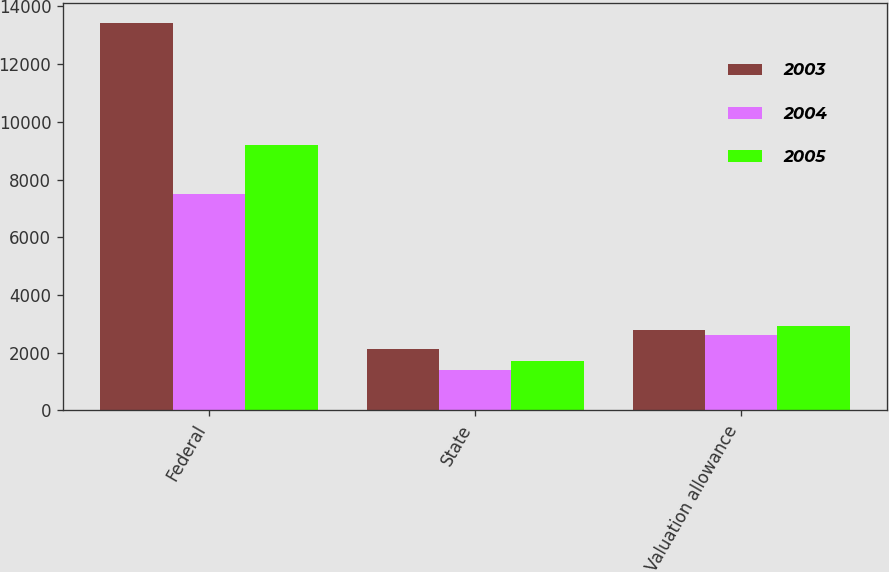Convert chart. <chart><loc_0><loc_0><loc_500><loc_500><stacked_bar_chart><ecel><fcel>Federal<fcel>State<fcel>Valuation allowance<nl><fcel>2003<fcel>13426<fcel>2115<fcel>2777<nl><fcel>2004<fcel>7487<fcel>1386<fcel>2612<nl><fcel>2005<fcel>9205<fcel>1705<fcel>2942<nl></chart> 